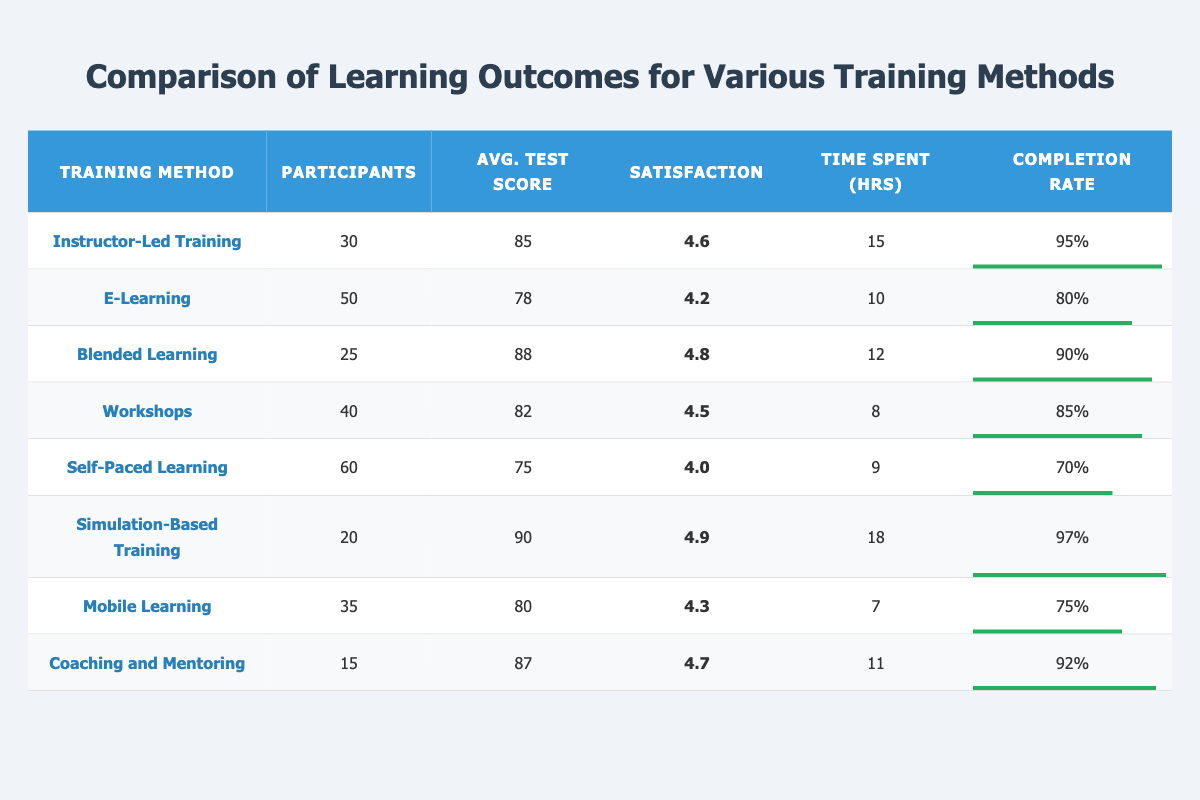What is the average test score of Simulation-Based Training? The average test score for Simulation-Based Training is listed directly in the table as 90.
Answer: 90 Which training method has the highest satisfaction rating? By inspecting the satisfaction rating column, Simulation-Based Training has the highest value of 4.9, which is greater than all other methods.
Answer: Simulation-Based Training How many participants took part in E-Learning? The table shows that E-Learning had 50 participants, which is stated directly in the participant count column.
Answer: 50 What is the completion rate for Self-Paced Learning? The table indicates that the completion rate for Self-Paced Learning is 70%, as seen in the completion rate column.
Answer: 70% Calculate the average time spent across all training methods. To find the average time, sum the hours spent for all methods (15 + 10 + 12 + 8 + 9 + 18 + 7 + 11 = 90) and divide by the count of methods (8). This results in an average of 90/8 = 11.25 hours.
Answer: 11.25 Is the completion rate of Blended Learning higher than that of Workshops? Comparing the completion rates from the table: Blended Learning has a rate of 90% and Workshops has a rate of 85%. Since 90% is greater than 85%, the statement is true.
Answer: Yes How many more participants attended Mobile Learning than Coaching and Mentoring? The participant counts are 35 for Mobile Learning and 15 for Coaching and Mentoring. Subtract the latter from the former: 35 - 15 = 20.
Answer: 20 Which training method had the lowest average test score? Looking at the average test scores in the table, Self-Paced Learning has the lowest score at 75 compared to all other methods.
Answer: Self-Paced Learning What percentage of participants completed the Instructor-Led Training? The completion rate for Instructor-Led Training is listed as 95%, which reflects the percentage of participants who completed the training.
Answer: 95% If we combine the participant counts for Workshops and Coaching and Mentoring, what is the total? The total participants: Workshops have 40 participants and Coaching and Mentoring have 15 participants. Summing them gives 40 + 15 = 55 participants.
Answer: 55 